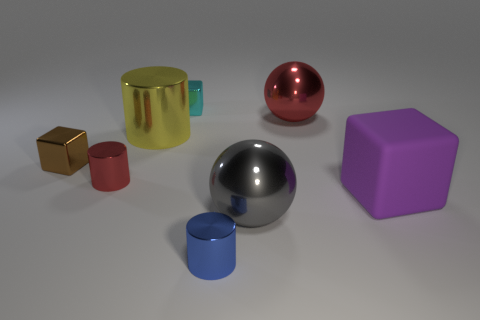Does the red shiny thing right of the yellow object have the same size as the tiny cyan metal thing?
Make the answer very short. No. Is the number of brown blocks in front of the brown thing less than the number of big green metal objects?
Give a very brief answer. No. There is a purple cube that is the same size as the yellow metallic cylinder; what material is it?
Your answer should be compact. Rubber. How many big objects are either blue rubber cubes or metallic cylinders?
Ensure brevity in your answer.  1. What number of objects are either large metal things that are to the right of the blue thing or small things that are behind the purple thing?
Offer a terse response. 5. Is the number of small cyan cubes less than the number of big cyan rubber spheres?
Your answer should be compact. No. The brown shiny object that is the same size as the cyan metallic object is what shape?
Offer a very short reply. Cube. How many blue objects are there?
Offer a very short reply. 1. What number of big shiny objects are both behind the large gray object and to the right of the blue cylinder?
Give a very brief answer. 1. What is the large block made of?
Your response must be concise. Rubber. 